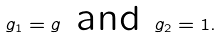<formula> <loc_0><loc_0><loc_500><loc_500>g _ { 1 } = g \text { and } g _ { 2 } = 1 .</formula> 